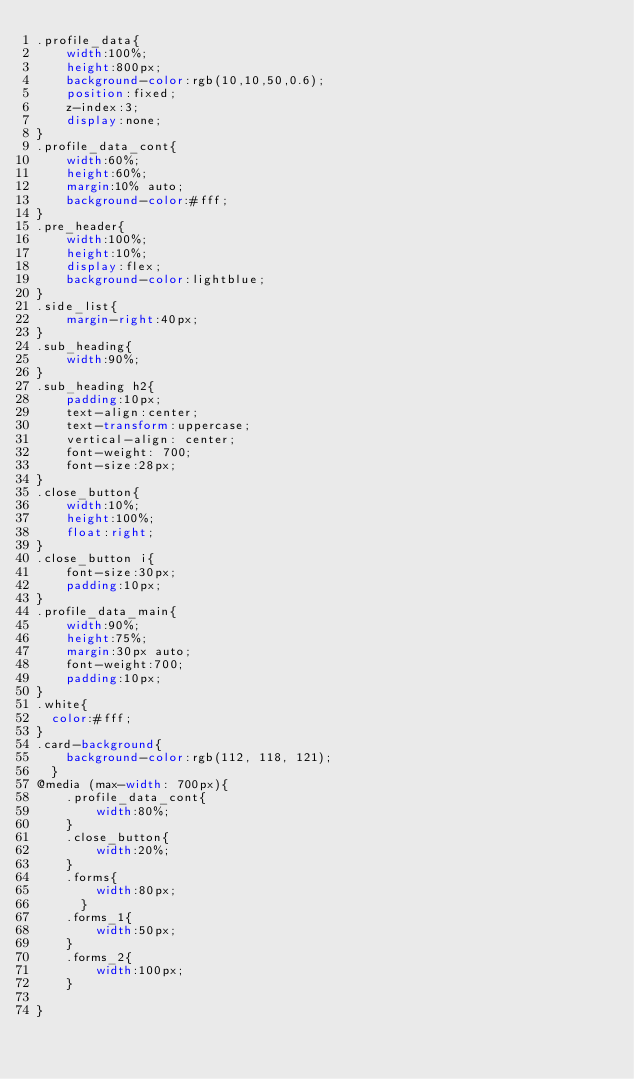<code> <loc_0><loc_0><loc_500><loc_500><_CSS_>.profile_data{
    width:100%;
    height:800px;
    background-color:rgb(10,10,50,0.6);
    position:fixed;
    z-index:3;
    display:none;
}
.profile_data_cont{
    width:60%;
    height:60%;
    margin:10% auto;
    background-color:#fff;
}
.pre_header{
    width:100%;
    height:10%;
    display:flex;
    background-color:lightblue;
}
.side_list{
    margin-right:40px;
}
.sub_heading{
    width:90%;
}
.sub_heading h2{
    padding:10px;
    text-align:center;
    text-transform:uppercase;
    vertical-align: center;
    font-weight: 700;
    font-size:28px;
}
.close_button{
    width:10%;
    height:100%;
    float:right;
}
.close_button i{
    font-size:30px;
    padding:10px;
}
.profile_data_main{
    width:90%;
    height:75%;
    margin:30px auto;
    font-weight:700;
    padding:10px;
}
.white{
  color:#fff;
}
.card-background{
    background-color:rgb(112, 118, 121);
  }
@media (max-width: 700px){
    .profile_data_cont{
        width:80%;
    }
    .close_button{
        width:20%;
    }
    .forms{
        width:80px;
      }
    .forms_1{
        width:50px;
    }
    .forms_2{
        width:100px;
    }
    
}</code> 